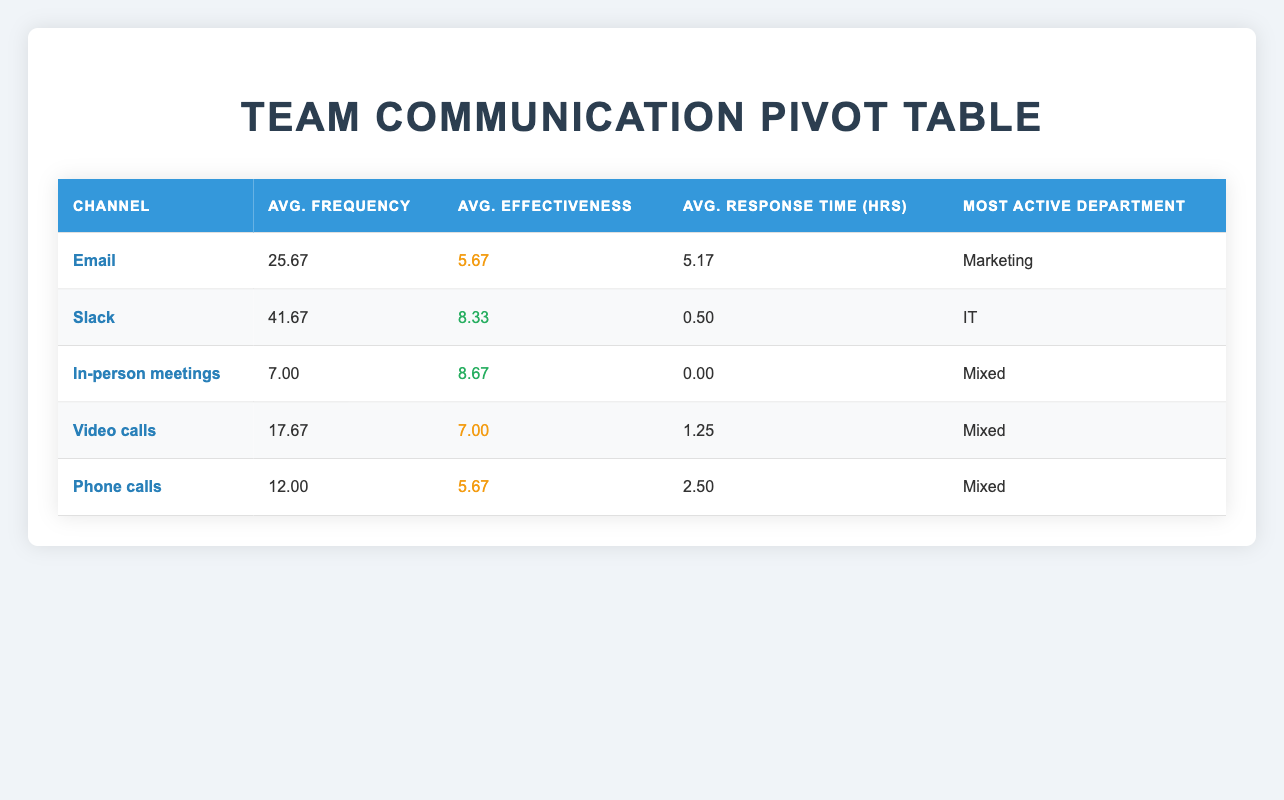What is the average effectiveness score for Slack as a communication channel? In the table, the effectiveness scores for Slack are 8, 9, and 8. To find the average, sum these values: 8 + 9 + 8 = 25 and divide by the number of occurrences, which is 3: 25 / 3 = 8.33.
Answer: 8.33 Which communication channel has the highest average frequency? The table shows that Slack has an average frequency of 41.67, which is the highest compared to other channels (Email has 25.67, In-person meetings has 7.00, Video calls has 17.67, and Phone calls has 12.00).
Answer: Slack Is the effectiveness score for Email greater than 6? The average effectiveness score for Email is 5.67 as indicated in the table. Therefore, it is not greater than 6.
Answer: No What is the combined average response time for Phone calls and Video calls? For Phone calls, the average response time is 2.50 hours, and for Video calls, it is 1.25 hours. To find the combined average, sum these two values: 2.50 + 1.25 = 3.75, then divide by the number of channels, which is 2: 3.75 / 2 = 1.875.
Answer: 1.875 Which department has the most active communication channel? The table indicates that the most active department is Marketing, which utilizes the Email channel with an average frequency of 25.67. Other departments have lower frequencies in their most utilized channels.
Answer: Marketing What is the average effectiveness score for all channels combined? The effectiveness scores are 6, 8, 9, 7, 6, 5, 9, 8, 7, 6, 6, 8, 9, 7, and 6. Summing these values gives 103. There are 15 scores in total, therefore the average is 103 / 15 = 6.87.
Answer: 6.87 Based on the table, is there any channel that has an average of 0 hours for response time? Yes, both In-person meetings and Slack channels show an average response time of 0 hours in the table.
Answer: Yes Which channel has the lowest average frequency, and what is that frequency? The channel with the lowest average frequency is In-person meetings with an average of 7.00. This value is directly available in the table.
Answer: In-person meetings, 7.00 